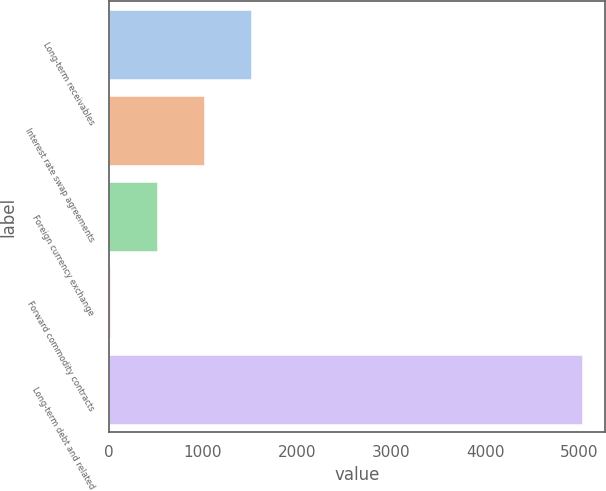<chart> <loc_0><loc_0><loc_500><loc_500><bar_chart><fcel>Long-term receivables<fcel>Interest rate swap agreements<fcel>Foreign currency exchange<fcel>Forward commodity contracts<fcel>Long-term debt and related<nl><fcel>1514.5<fcel>1013<fcel>511.5<fcel>10<fcel>5025<nl></chart> 